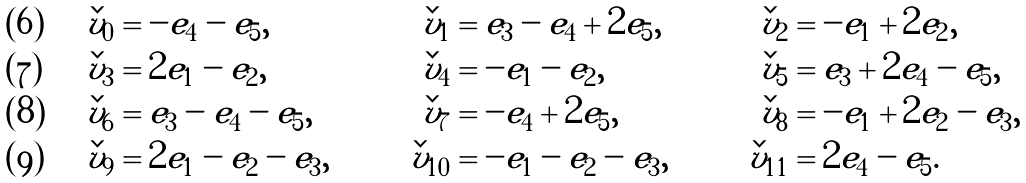Convert formula to latex. <formula><loc_0><loc_0><loc_500><loc_500>\check { v } _ { 0 } & = - e _ { 4 } - e _ { 5 } , & \check { v } _ { 1 } & = e _ { 3 } - e _ { 4 } + 2 e _ { 5 } , & \check { v } _ { 2 } & = - e _ { 1 } + 2 e _ { 2 } , \\ \check { v } _ { 3 } & = 2 e _ { 1 } - e _ { 2 } , & \check { v } _ { 4 } & = - e _ { 1 } - e _ { 2 } , & \check { v } _ { 5 } & = e _ { 3 } + 2 e _ { 4 } - e _ { 5 } , \\ \check { v } _ { 6 } & = e _ { 3 } - e _ { 4 } - e _ { 5 } , & \check { v } _ { 7 } & = - e _ { 4 } + 2 e _ { 5 } , & \check { v } _ { 8 } & = - e _ { 1 } + 2 e _ { 2 } - e _ { 3 } , \\ \check { v } _ { 9 } & = 2 e _ { 1 } - e _ { 2 } - e _ { 3 } , & \check { v } _ { 1 0 } & = - e _ { 1 } - e _ { 2 } - e _ { 3 } , & \check { v } _ { 1 1 } & = 2 e _ { 4 } - e _ { 5 } .</formula> 